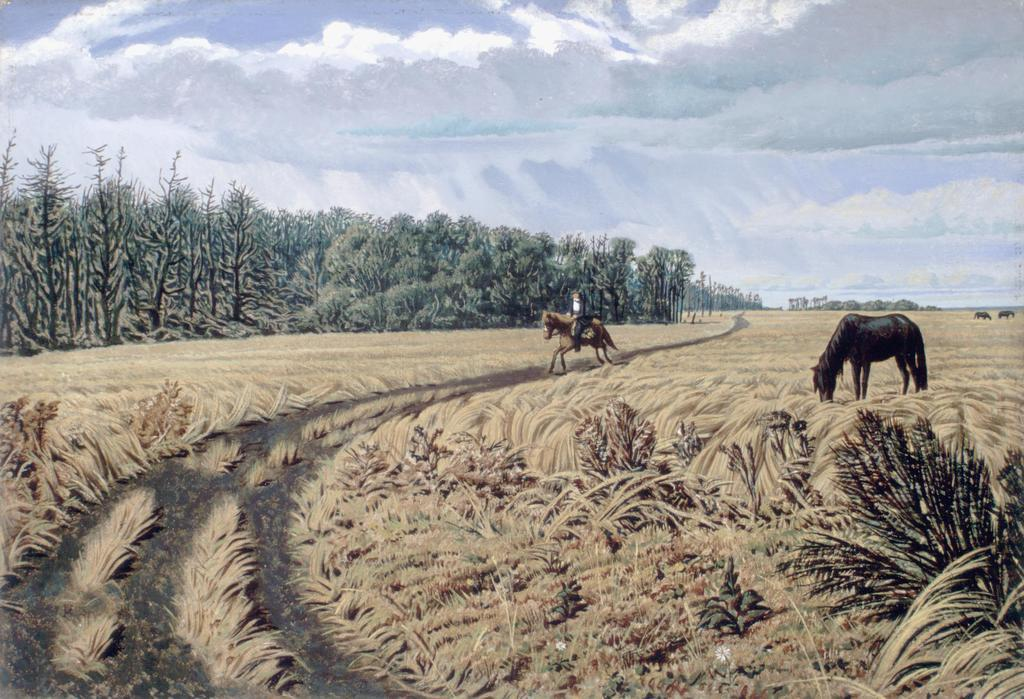What type of terrain is shown in the image? The image depicts a dry grassland. What is the person in the image doing? The person is riding a horse in the image. Are there any other horses in the image? Yes, there is another horse on the right side of the image. What else can be seen in the image besides the grassland and horses? Trees and the sky are visible in the image. Can you tell me which actor is playing the role of the person on the horse in the image? There is no actor or role-playing in the image; it is a depiction of a person riding a horse in a dry grassland. How many wrens can be seen in the image? There are no wrens present in the image. 